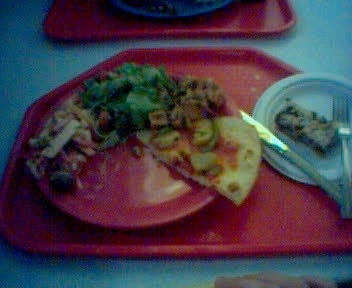Describe the objects in this image and their specific colors. I can see dining table in navy, blue, teal, and gray tones, pizza in navy, olive, maroon, and gray tones, knife in navy, teal, and aquamarine tones, and fork in navy and teal tones in this image. 